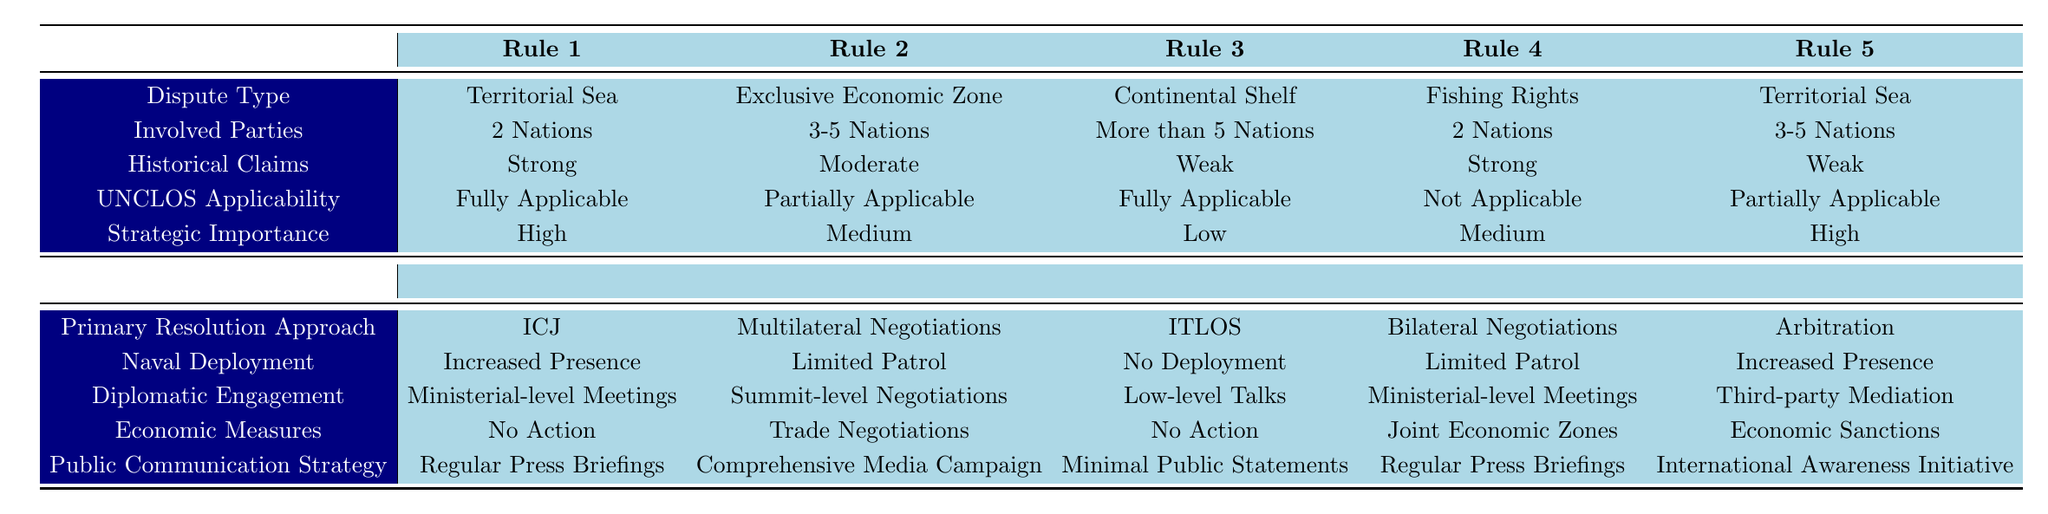What is the primary resolution approach for disputes involving two nations with strong historical claims over territorial sea? According to Rule 1, for a dispute type of Territorial Sea with 2 Nations involved and Strong historical claims, the primary resolution approach is through the International Court of Justice (ICJ).
Answer: International Court of Justice (ICJ) Which dispute type has a primary resolution approach of multilateral negotiations? Rule 2 indicates that the Exclusive Economic Zone dispute type with 3-5 Nations, Moderate historical claims, and Partially applicable UNCLOS has Multilateral Negotiations as its primary resolution approach.
Answer: Exclusive Economic Zone Is there a situation where economic measures involve no action? Yes, Rule 1 involving Territorial Sea with 2 Nations and Strong historical claims indicates that the economic measures are "No Action." Additionally, Rule 3 involving Continental Shelf with more than 5 Nations and Weak claims also states "No Action" for economic measures.
Answer: Yes What is the naval deployment strategy when the involved parties are more than five nations with weak claims over the continental shelf? According to Rule 3, when more than 5 Nations are involved in a Continental Shelf dispute with Weak historical claims, the naval deployment strategy is listed as No Deployment.
Answer: No Deployment How many distinct actions are there for the primary resolution approach across all rules? The primary resolution approach options are ICJ, Multilateral Negotiations, ITLOS, Bilateral Negotiations, Arbitration, and Joint Development Agreement. This results in 6 distinct actions across the rules provided.
Answer: 6 